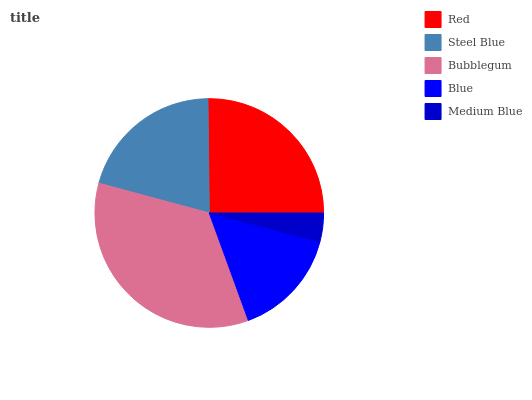Is Medium Blue the minimum?
Answer yes or no. Yes. Is Bubblegum the maximum?
Answer yes or no. Yes. Is Steel Blue the minimum?
Answer yes or no. No. Is Steel Blue the maximum?
Answer yes or no. No. Is Red greater than Steel Blue?
Answer yes or no. Yes. Is Steel Blue less than Red?
Answer yes or no. Yes. Is Steel Blue greater than Red?
Answer yes or no. No. Is Red less than Steel Blue?
Answer yes or no. No. Is Steel Blue the high median?
Answer yes or no. Yes. Is Steel Blue the low median?
Answer yes or no. Yes. Is Medium Blue the high median?
Answer yes or no. No. Is Bubblegum the low median?
Answer yes or no. No. 